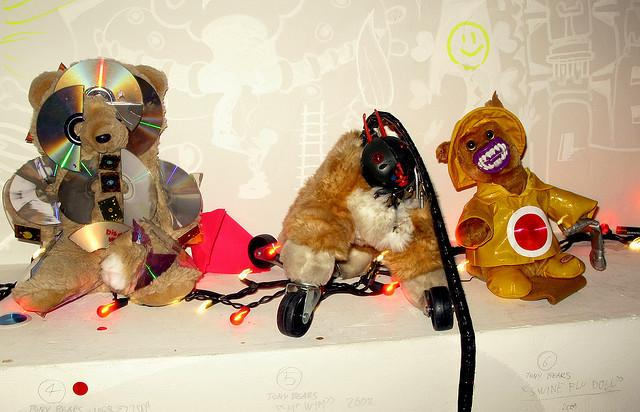What are the shattered items on the bear? cds 